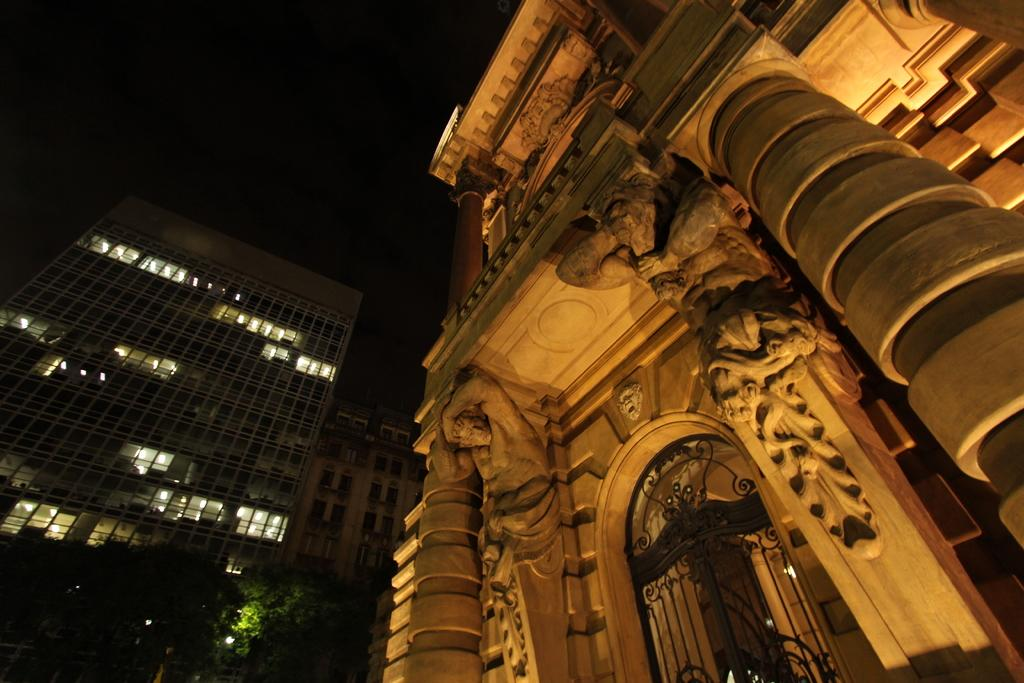What type of decorations can be seen on the building in the image? There are statues on the building in the image. What type of entrance is visible in the image? There is a grilled gate in the image. What type of structures can be seen in the image? There are buildings visible in the image. What type of vegetation is present in the image? There are trees in the image. What part of the natural environment is visible in the image? The sky is visible in the image. What type of potato can be seen growing on the trees in the image? There are no potatoes present in the image; it features trees and buildings. What time of day is it in the image, considering the visibility of the sky? The time of day cannot be determined from the image, as the sky is visible but no specific details about the lighting or shadows are provided. 